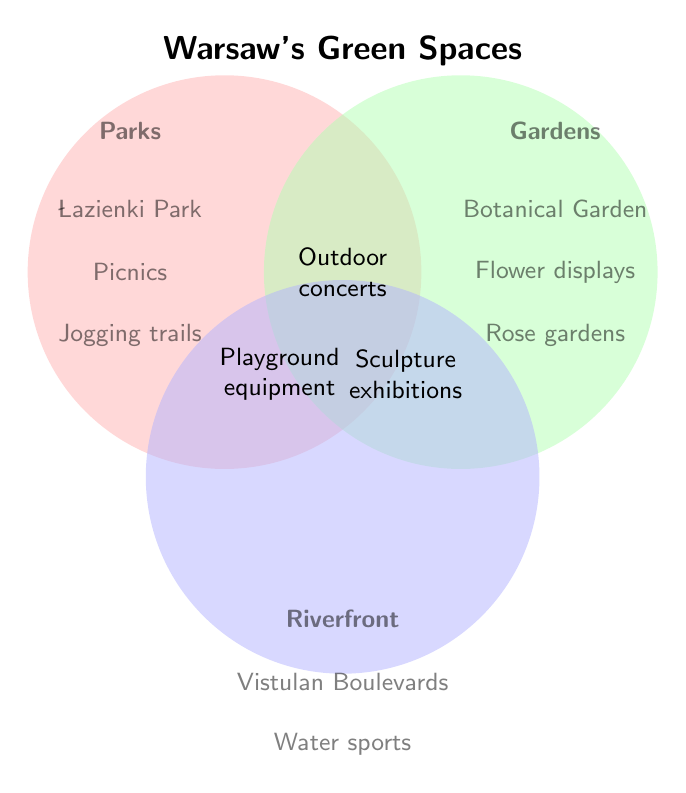What is the title of the Venn Diagram? The title is located at the top center of the figure, stating the overall topic it represents.
Answer: Warsaw's Green Spaces Which green space category includes the Vistulan Boulevards? The Vistulan Boulevards are listed within the "Riverfront" category, as noted by their location in the blue circle at the bottom.
Answer: Riverfront Which elements are common to Parks and Riverfront areas? Common elements appear in the overlapping section between Parks and Riverfront circles.
Answer: Outdoor concerts, Sculpture exhibitions, Playground equipment What facilities are unique to Gardens? Unique facilities for Gardens are listed solely within the green circle, without overlap with Parks or Riverfront areas.
Answer: Flower displays, Rose gardens, Botanical Garden Which green space has the most unique activities listed? Count the unique activities for each category by examining the lists provided solely within each circle.
Answer: Gardens Which green space category offers Boat rentals? Determine by checking where the term "Boat rentals" is located within the circles.
Answer: Riverfront areas Are there any activities exclusive to Parks? If so, name one. Review the activities listed solely within the red circle for Parks.
Answer: Picnics Is there an activity shared among all three green spaces? Check the overlapping central area common to all three circles for any shared activities.
Answer: None How many activities are shared between Parks and Gardens? Identify and count the elements appearing in the overlapping section between Parks and Gardens.
Answer: Three Which category features "Seasonal plantings"? Locate where "Seasonal plantings" is mentioned within the circles.
Answer: Gardens 